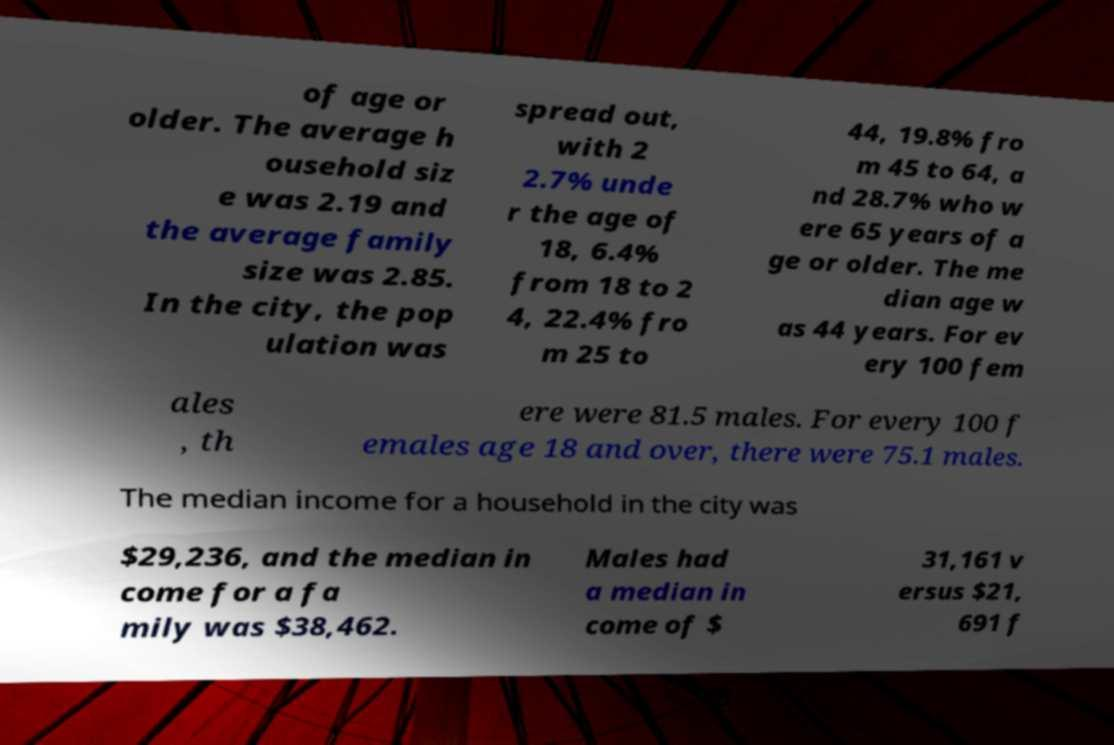Could you extract and type out the text from this image? of age or older. The average h ousehold siz e was 2.19 and the average family size was 2.85. In the city, the pop ulation was spread out, with 2 2.7% unde r the age of 18, 6.4% from 18 to 2 4, 22.4% fro m 25 to 44, 19.8% fro m 45 to 64, a nd 28.7% who w ere 65 years of a ge or older. The me dian age w as 44 years. For ev ery 100 fem ales , th ere were 81.5 males. For every 100 f emales age 18 and over, there were 75.1 males. The median income for a household in the city was $29,236, and the median in come for a fa mily was $38,462. Males had a median in come of $ 31,161 v ersus $21, 691 f 